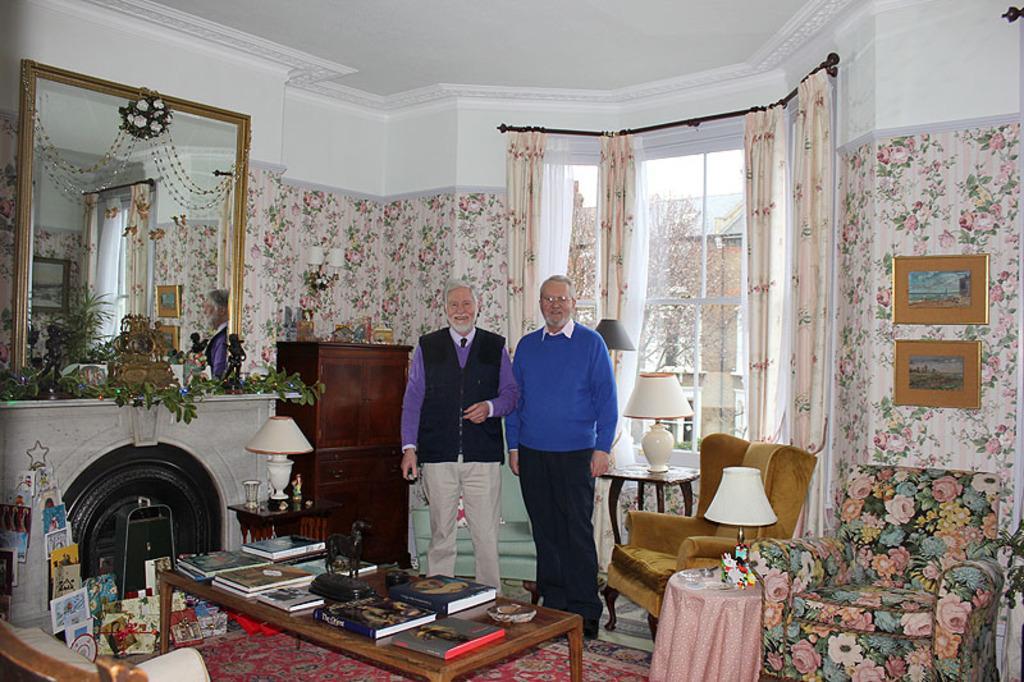Describe this image in one or two sentences. There are two members standing in this picture in the hall in front of a table on which some books were placed. There are some chairs and a lamp which is placed on the stool. In the background there are some curtains, Windows and a photo frames attached to the wall. There is a mirror and the left side. 